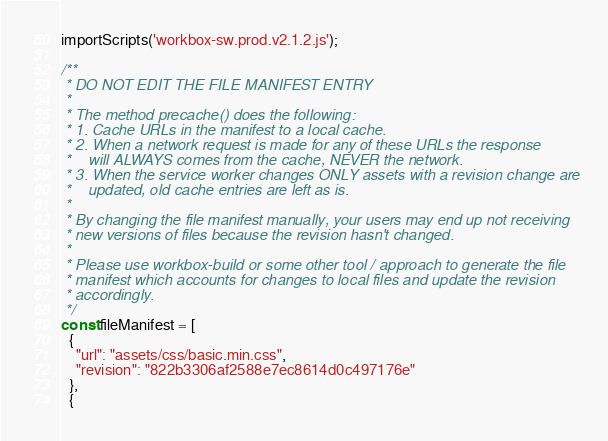<code> <loc_0><loc_0><loc_500><loc_500><_JavaScript_>importScripts('workbox-sw.prod.v2.1.2.js');

/**
 * DO NOT EDIT THE FILE MANIFEST ENTRY
 *
 * The method precache() does the following:
 * 1. Cache URLs in the manifest to a local cache.
 * 2. When a network request is made for any of these URLs the response
 *    will ALWAYS comes from the cache, NEVER the network.
 * 3. When the service worker changes ONLY assets with a revision change are
 *    updated, old cache entries are left as is.
 *
 * By changing the file manifest manually, your users may end up not receiving
 * new versions of files because the revision hasn't changed.
 *
 * Please use workbox-build or some other tool / approach to generate the file
 * manifest which accounts for changes to local files and update the revision
 * accordingly.
 */
const fileManifest = [
  {
    "url": "assets/css/basic.min.css",
    "revision": "822b3306af2588e7ec8614d0c497176e"
  },
  {</code> 